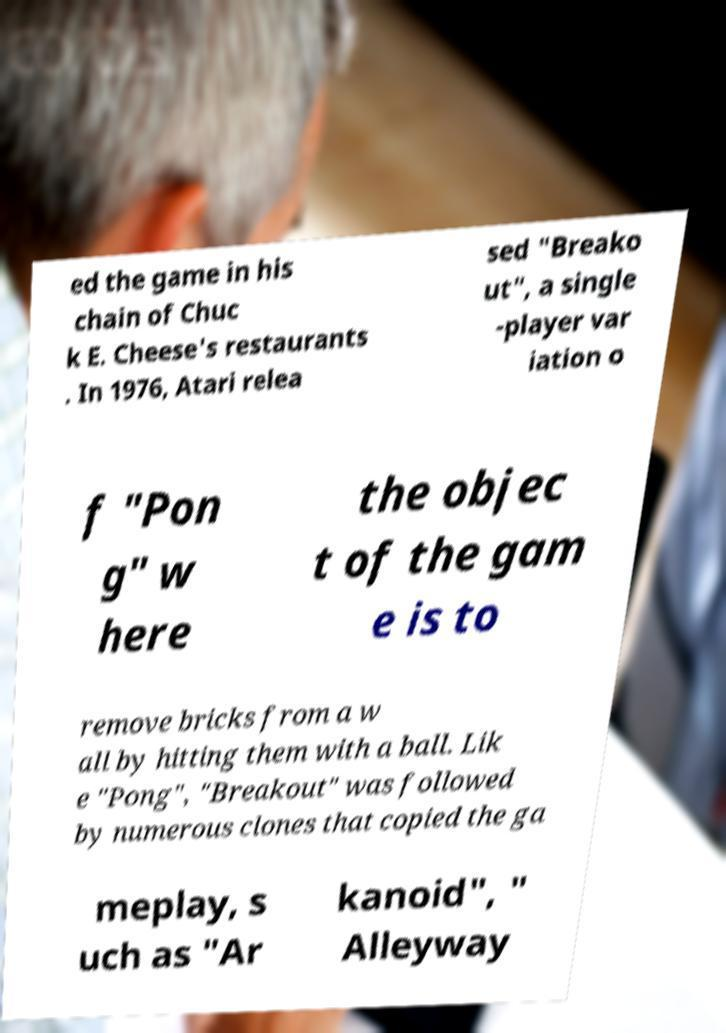Please read and relay the text visible in this image. What does it say? ed the game in his chain of Chuc k E. Cheese's restaurants . In 1976, Atari relea sed "Breako ut", a single -player var iation o f "Pon g" w here the objec t of the gam e is to remove bricks from a w all by hitting them with a ball. Lik e "Pong", "Breakout" was followed by numerous clones that copied the ga meplay, s uch as "Ar kanoid", " Alleyway 